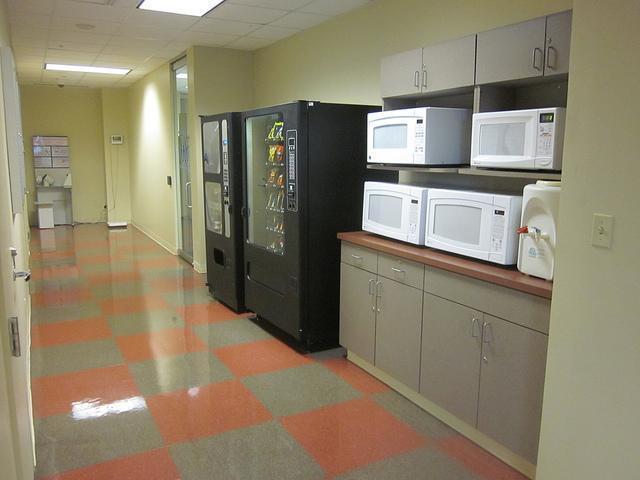How many people can cook food here at once?
Indicate the correct response by choosing from the four available options to answer the question.
Options: Four, two, one, six. Four. 